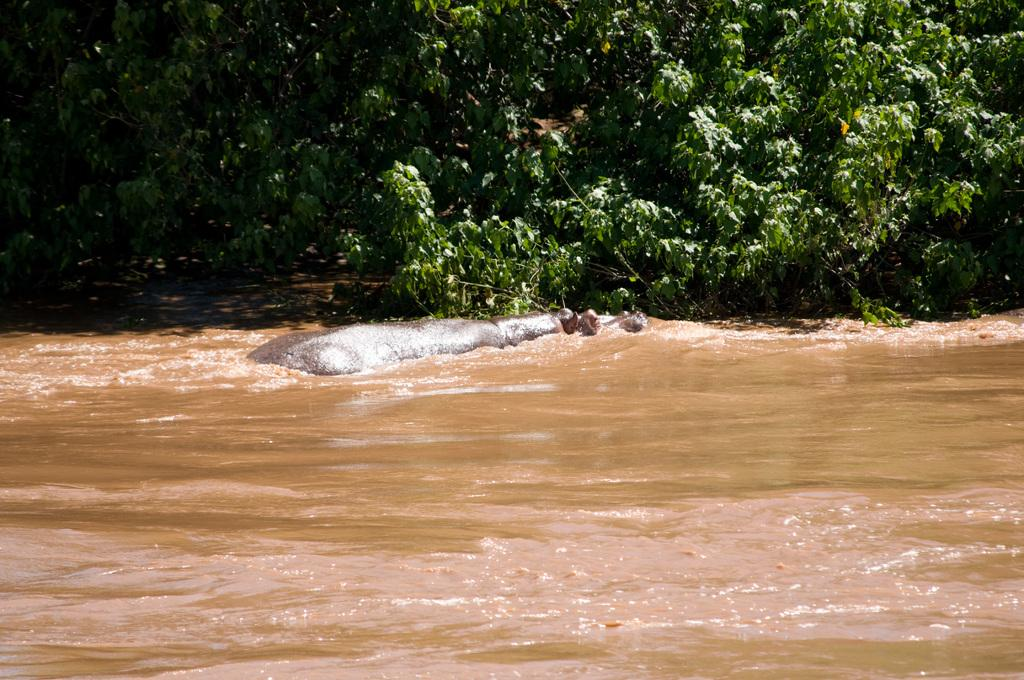What animal is in the water in the image? There is a hippopotamus in the water in the image. What can be seen in the background of the image? There are trees in the background of the image. What type of light is being used to express love in the image? There is no light or expression of love present in the image; it features a hippopotamus in the water and trees in the background. 